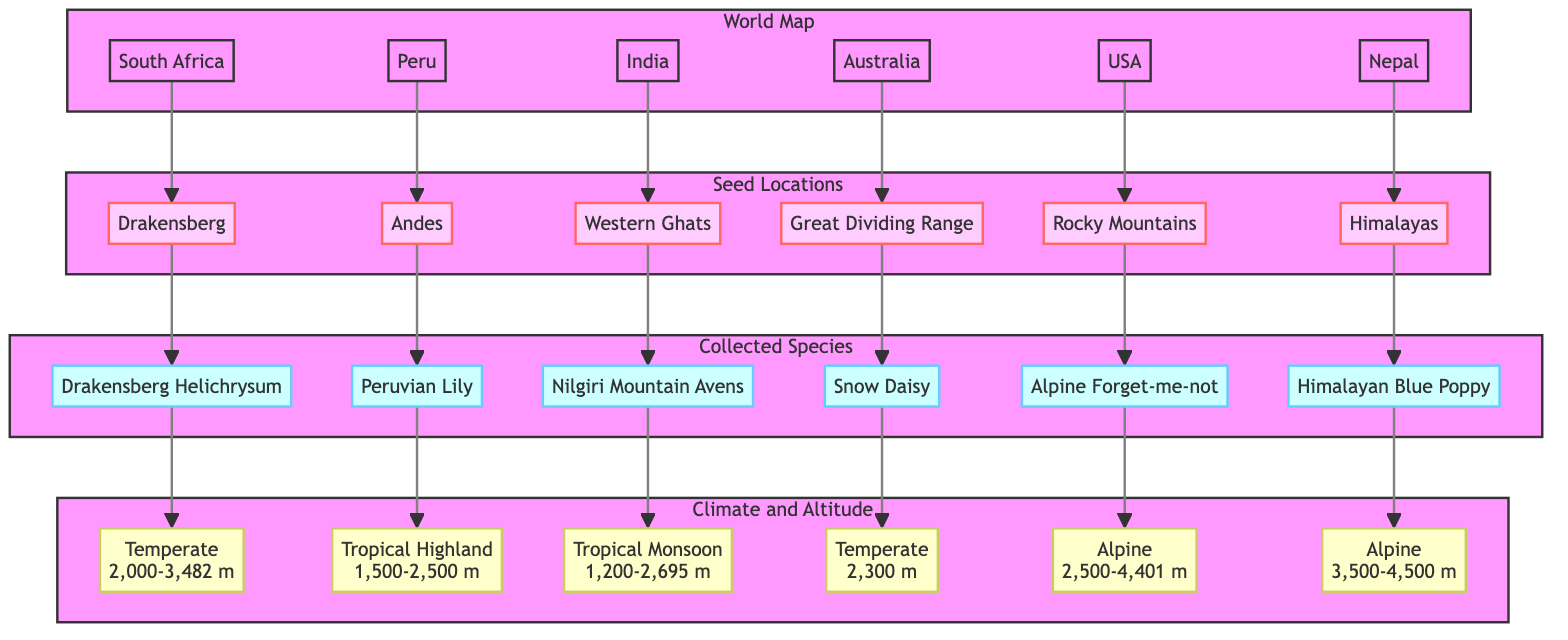What is the highest altitude associated with the Himalayan Blue Poppy? The diagram indicates that the Himalayan Blue Poppy is found at an altitude range of 3,500-4,500 m, which denotes the highest altitude it is associated with.
Answer: 4,500 m Which region in India is associated with the Nilgiri Mountain Avens? Referring to the diagram, the Nilgiri Mountain Avens is located in the Western Ghats region of India, which is directly connected to that species in the visual representation.
Answer: Western Ghats How many rare flower species are indicated in the diagram? By counting the species listed under the "Collected Species" section, there are a total of 6 rare flower species shown in the diagram: Drakensberg Helichrysum, Peruvian Lily, Nilgiri Mountain Avens, Snow Daisy, Alpine Forget-me-not, and Himalayan Blue Poppy.
Answer: 6 What climate type is associated with the Drakensberg Helichrysum? The diagram shows that the Drakensberg Helichrysum is categorized under the "Temperate" climate type with an altitude range of 2,000-3,482 m, linking the species to this specific climate information in the visual.
Answer: Temperate Which flower species is collected in the Andes region? The diagram specifies that the flower species collected in the Andes region of Peru is the Peruvian Lily, as indicated by the direct connection in the representation.
Answer: Peruvian Lily Which two collected species are associated with Alpine climate? To determine the collected species associated with an Alpine climate in the diagram, we can look at the Alpine Forget-me-not and the Himalayan Blue Poppy, both of which fall under the Alpine climate category in different altitude ranges.
Answer: Alpine Forget-me-not, Himalayan Blue Poppy What is the altitude range for the Snow Daisy? According to the diagram, the Snow Daisy is depicted as having an altitude range of 2,300 m, providing a clear understanding of where this species can be found.
Answer: 2,300 m In how many regions has seed collection been marked in the diagram? The diagram lists seeds collected from 6 distinct regions: South Africa, Peru, India, Australia, USA, and Nepal, counting the geographical distribution connections to each region mentioned.
Answer: 6 What is the lowest altitude associated with the Tropical Monsoon climate? By examining the climate associated with the Nilgiri Mountain Avens in the diagram, which has an altitude range starting at 1,200 m, we can conclude this is the lowest altitude within the Tropical Monsoon climate type shown.
Answer: 1,200 m 